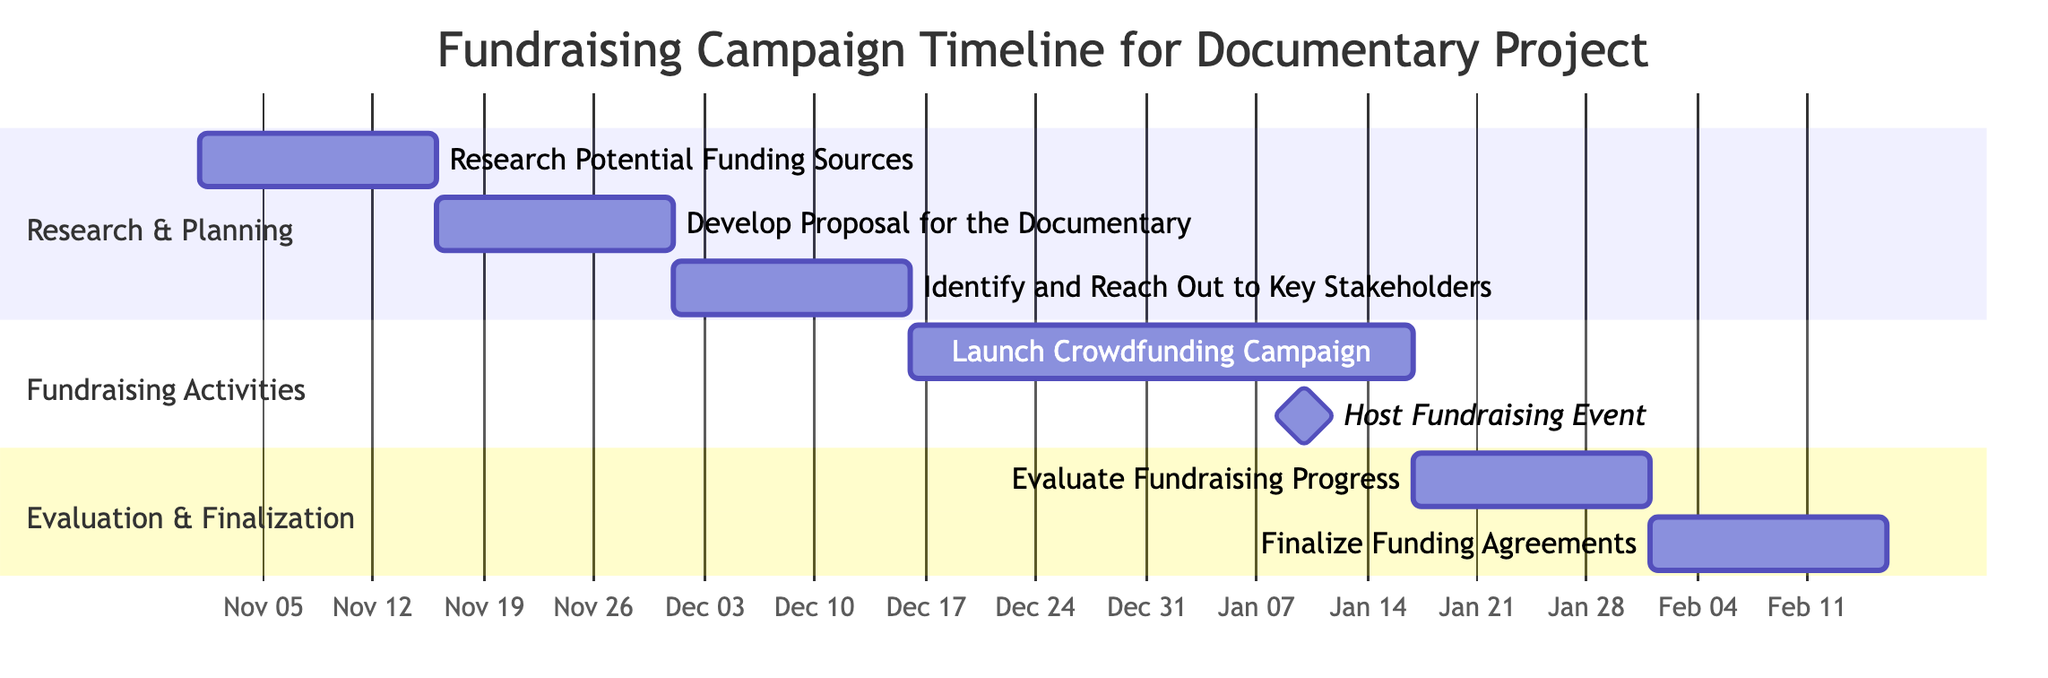What is the duration of the "Research Potential Funding Sources" task? The “Research Potential Funding Sources” task starts on November 1, 2023, and ends on November 15, 2023. This is a total duration of 15 days.
Answer: 15 days When does the "Develop Proposal for the Documentary" task start? The task “Develop Proposal for the Documentary” begins immediately after the completion of “Research Potential Funding Sources,” which ends on November 15, 2023. Thus, it starts on November 16, 2023.
Answer: November 16, 2023 How many tasks are in the "Fundraising Activities" section? The “Fundraising Activities” section contains two tasks: “Launch Crowdfunding Campaign” and “Host Fundraising Event.” Therefore, the count of tasks in this section is two.
Answer: 2 What is the end date of the "Finalize Funding Agreements" task? The "Finalize Funding Agreements" task starts after the “Evaluate Fundraising Progress,” which ends on January 31, 2024. Therefore, it starts on February 1, 2024, and ends on February 15, 2024. Therefore, the end date is February 15, 2024.
Answer: February 15, 2024 What task overlaps with the "Launch Crowdfunding Campaign"? The "Host Fundraising Event" is scheduled for January 10, 2024, which overlaps with the "Launch Crowdfunding Campaign" that continues until January 16, 2024. This means that both tasks are happening simultaneously from January 10 to January 16, 2024.
Answer: Host Fundraising Event What is the total duration of the evaluation phase? The “Evaluate Fundraising Progress” task lasts for 15 days from January 17, 2024, to January 31, 2024. The following task, “Finalize Funding Agreements,” also lasts for 15 days. The entire evaluation phase includes both tasks, leading to a total of 30 days for evaluation.
Answer: 30 days 